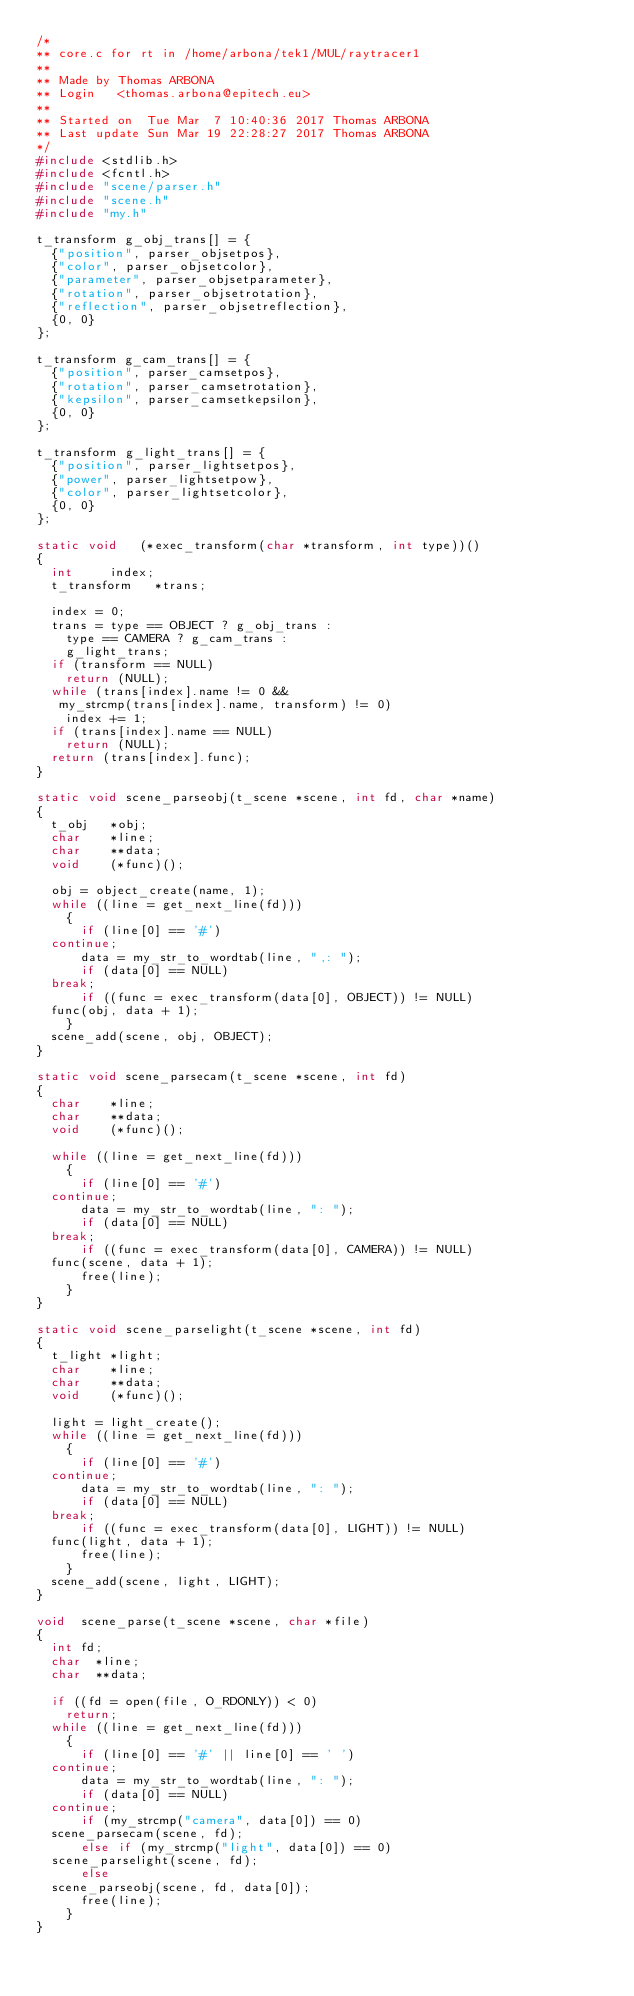<code> <loc_0><loc_0><loc_500><loc_500><_C_>/*
** core.c for rt in /home/arbona/tek1/MUL/raytracer1
**
** Made by Thomas ARBONA
** Login   <thomas.arbona@epitech.eu>
**
** Started on  Tue Mar  7 10:40:36 2017 Thomas ARBONA
** Last update Sun Mar 19 22:28:27 2017 Thomas ARBONA
*/
#include <stdlib.h>
#include <fcntl.h>
#include "scene/parser.h"
#include "scene.h"
#include "my.h"

t_transform	g_obj_trans[] = {
  {"position", parser_objsetpos},
  {"color", parser_objsetcolor},
  {"parameter", parser_objsetparameter},
  {"rotation", parser_objsetrotation},
  {"reflection", parser_objsetreflection},
  {0, 0}
};

t_transform g_cam_trans[] = {
  {"position", parser_camsetpos},
  {"rotation", parser_camsetrotation},
  {"kepsilon", parser_camsetkepsilon},
  {0, 0}
};

t_transform g_light_trans[] = {
  {"position", parser_lightsetpos},
  {"power", parser_lightsetpow},
  {"color", parser_lightsetcolor},
  {0, 0}
};

static void		(*exec_transform(char *transform, int type))()
{
  int			index;
  t_transform		*trans;

  index = 0;
  trans = type == OBJECT ? g_obj_trans :
    type == CAMERA ? g_cam_trans :
    g_light_trans;
  if (transform == NULL)
    return (NULL);
  while (trans[index].name != 0 &&
	 my_strcmp(trans[index].name, transform) != 0)
    index += 1;
  if (trans[index].name == NULL)
    return (NULL);
  return (trans[index].func);
}

static void	scene_parseobj(t_scene *scene, int fd, char *name)
{
  t_obj		*obj;
  char		*line;
  char		**data;
  void		(*func)();

  obj = object_create(name, 1);
  while ((line = get_next_line(fd)))
    {
      if (line[0] == '#')
	continue;
      data = my_str_to_wordtab(line, ",: ");
      if (data[0] == NULL)
	break;
      if ((func = exec_transform(data[0], OBJECT)) != NULL)
	func(obj, data + 1);
    }
  scene_add(scene, obj, OBJECT);
}

static void	scene_parsecam(t_scene *scene, int fd)
{
  char		*line;
  char		**data;
  void		(*func)();

  while ((line = get_next_line(fd)))
    {
      if (line[0] == '#')
	continue;
      data = my_str_to_wordtab(line, ": ");
      if (data[0] == NULL)
	break;
      if ((func = exec_transform(data[0], CAMERA)) != NULL)
	func(scene, data + 1);
      free(line);
    }
}

static void	scene_parselight(t_scene *scene, int fd)
{
  t_light	*light;
  char		*line;
  char		**data;
  void		(*func)();

  light = light_create();
  while ((line = get_next_line(fd)))
    {
      if (line[0] == '#')
	continue;
      data = my_str_to_wordtab(line, ": ");
      if (data[0] == NULL)
	break;
      if ((func = exec_transform(data[0], LIGHT)) != NULL)
	func(light, data + 1);
      free(line);
    }
  scene_add(scene, light, LIGHT);
}

void	scene_parse(t_scene *scene, char *file)
{
  int	fd;
  char	*line;
  char	**data;

  if ((fd = open(file, O_RDONLY)) < 0)
    return;
  while ((line = get_next_line(fd)))
    {
      if (line[0] == '#' || line[0] == ' ')
	continue;
      data = my_str_to_wordtab(line, ": ");
      if (data[0] == NULL)
	continue;
      if (my_strcmp("camera", data[0]) == 0)
	scene_parsecam(scene, fd);
      else if (my_strcmp("light", data[0]) == 0)
	scene_parselight(scene, fd);
      else
	scene_parseobj(scene, fd, data[0]);
      free(line);
    }
}
</code> 